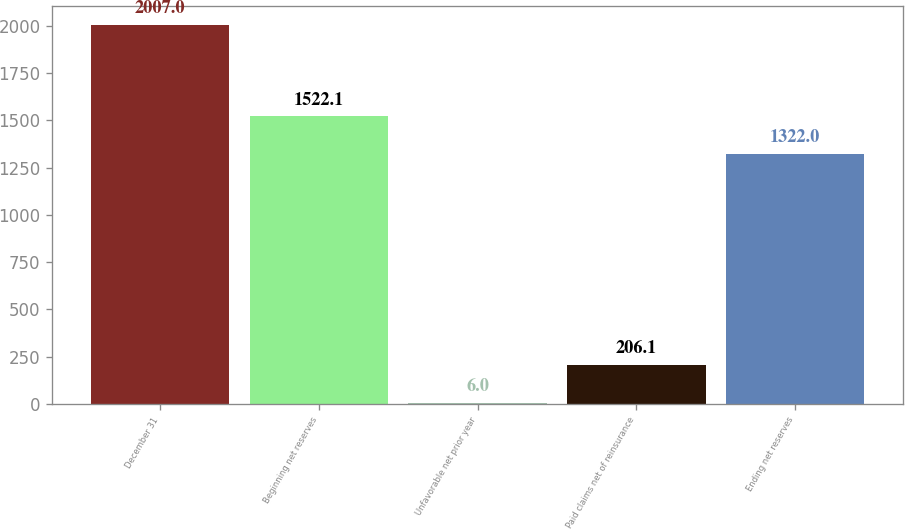Convert chart. <chart><loc_0><loc_0><loc_500><loc_500><bar_chart><fcel>December 31<fcel>Beginning net reserves<fcel>Unfavorable net prior year<fcel>Paid claims net of reinsurance<fcel>Ending net reserves<nl><fcel>2007<fcel>1522.1<fcel>6<fcel>206.1<fcel>1322<nl></chart> 